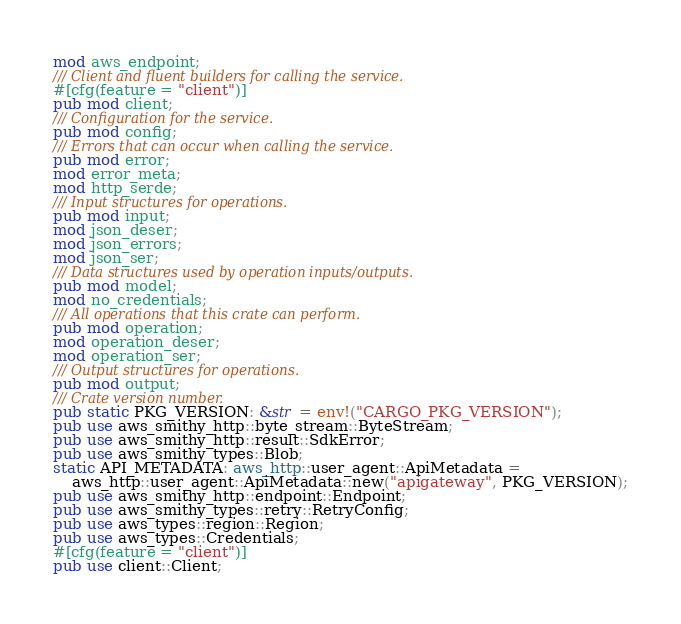Convert code to text. <code><loc_0><loc_0><loc_500><loc_500><_Rust_>
mod aws_endpoint;
/// Client and fluent builders for calling the service.
#[cfg(feature = "client")]
pub mod client;
/// Configuration for the service.
pub mod config;
/// Errors that can occur when calling the service.
pub mod error;
mod error_meta;
mod http_serde;
/// Input structures for operations.
pub mod input;
mod json_deser;
mod json_errors;
mod json_ser;
/// Data structures used by operation inputs/outputs.
pub mod model;
mod no_credentials;
/// All operations that this crate can perform.
pub mod operation;
mod operation_deser;
mod operation_ser;
/// Output structures for operations.
pub mod output;
/// Crate version number.
pub static PKG_VERSION: &str = env!("CARGO_PKG_VERSION");
pub use aws_smithy_http::byte_stream::ByteStream;
pub use aws_smithy_http::result::SdkError;
pub use aws_smithy_types::Blob;
static API_METADATA: aws_http::user_agent::ApiMetadata =
    aws_http::user_agent::ApiMetadata::new("apigateway", PKG_VERSION);
pub use aws_smithy_http::endpoint::Endpoint;
pub use aws_smithy_types::retry::RetryConfig;
pub use aws_types::region::Region;
pub use aws_types::Credentials;
#[cfg(feature = "client")]
pub use client::Client;
</code> 